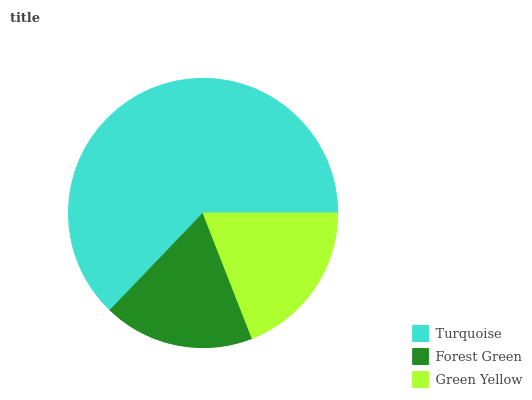Is Forest Green the minimum?
Answer yes or no. Yes. Is Turquoise the maximum?
Answer yes or no. Yes. Is Green Yellow the minimum?
Answer yes or no. No. Is Green Yellow the maximum?
Answer yes or no. No. Is Green Yellow greater than Forest Green?
Answer yes or no. Yes. Is Forest Green less than Green Yellow?
Answer yes or no. Yes. Is Forest Green greater than Green Yellow?
Answer yes or no. No. Is Green Yellow less than Forest Green?
Answer yes or no. No. Is Green Yellow the high median?
Answer yes or no. Yes. Is Green Yellow the low median?
Answer yes or no. Yes. Is Turquoise the high median?
Answer yes or no. No. Is Turquoise the low median?
Answer yes or no. No. 